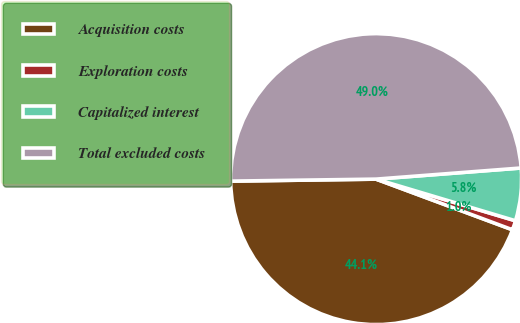Convert chart to OTSL. <chart><loc_0><loc_0><loc_500><loc_500><pie_chart><fcel>Acquisition costs<fcel>Exploration costs<fcel>Capitalized interest<fcel>Total excluded costs<nl><fcel>44.12%<fcel>1.04%<fcel>5.84%<fcel>49.0%<nl></chart> 